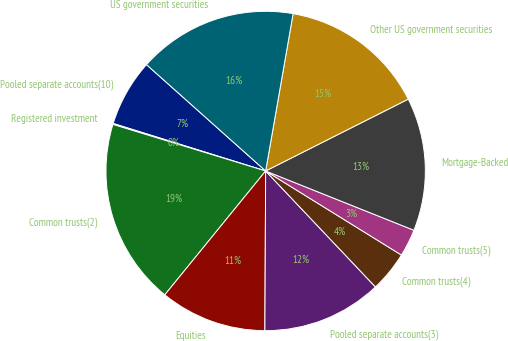Convert chart. <chart><loc_0><loc_0><loc_500><loc_500><pie_chart><fcel>Pooled separate accounts(10)<fcel>Registered investment<fcel>Common trusts(2)<fcel>Equities<fcel>Pooled separate accounts(3)<fcel>Common trusts(4)<fcel>Common trusts(5)<fcel>Mortgage-Backed<fcel>Other US government securities<fcel>US government securities<nl><fcel>6.79%<fcel>0.1%<fcel>18.83%<fcel>10.8%<fcel>12.14%<fcel>4.11%<fcel>2.77%<fcel>13.48%<fcel>14.82%<fcel>16.15%<nl></chart> 